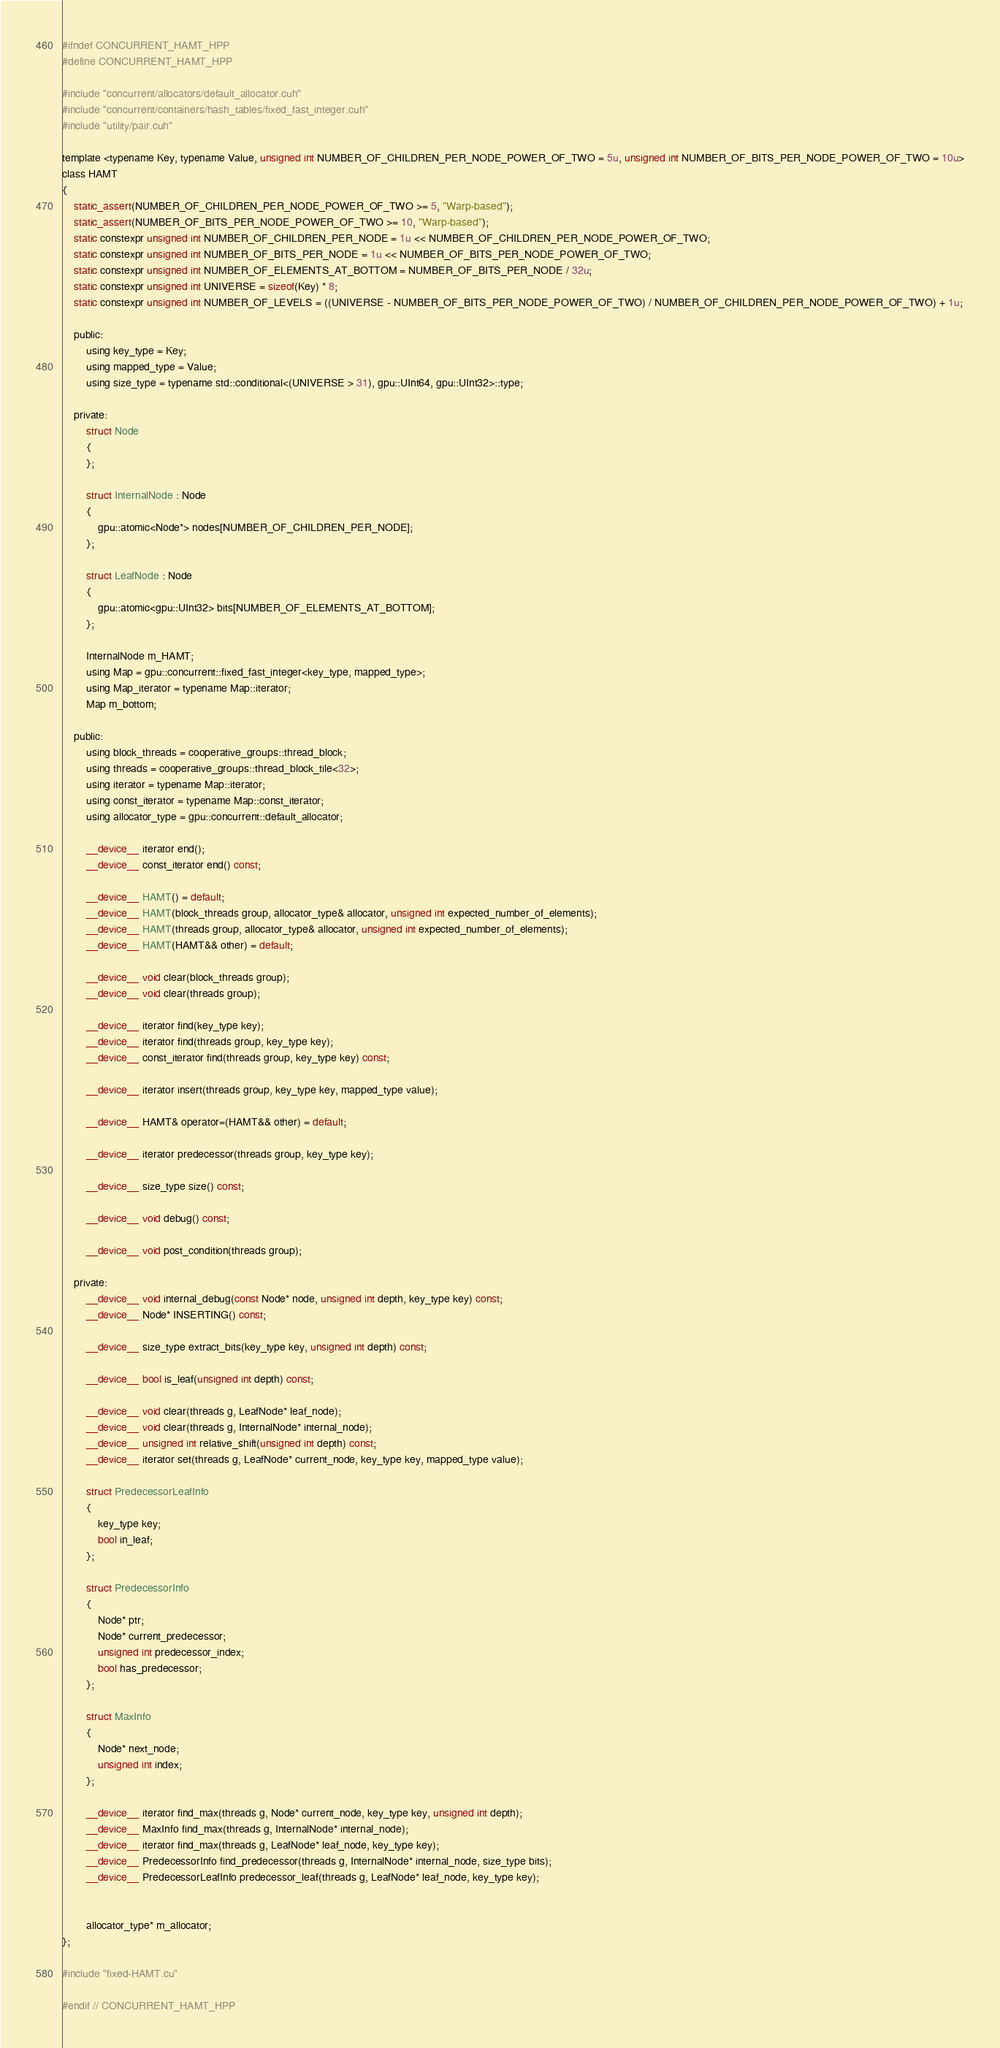<code> <loc_0><loc_0><loc_500><loc_500><_Cuda_>#ifndef CONCURRENT_HAMT_HPP
#define CONCURRENT_HAMT_HPP

#include "concurrent/allocators/default_allocator.cuh"
#include "concurrent/containers/hash_tables/fixed_fast_integer.cuh"
#include "utility/pair.cuh"

template <typename Key, typename Value, unsigned int NUMBER_OF_CHILDREN_PER_NODE_POWER_OF_TWO = 5u, unsigned int NUMBER_OF_BITS_PER_NODE_POWER_OF_TWO = 10u>
class HAMT
{
	static_assert(NUMBER_OF_CHILDREN_PER_NODE_POWER_OF_TWO >= 5, "Warp-based");
	static_assert(NUMBER_OF_BITS_PER_NODE_POWER_OF_TWO >= 10, "Warp-based");
	static constexpr unsigned int NUMBER_OF_CHILDREN_PER_NODE = 1u << NUMBER_OF_CHILDREN_PER_NODE_POWER_OF_TWO;
	static constexpr unsigned int NUMBER_OF_BITS_PER_NODE = 1u << NUMBER_OF_BITS_PER_NODE_POWER_OF_TWO;
	static constexpr unsigned int NUMBER_OF_ELEMENTS_AT_BOTTOM = NUMBER_OF_BITS_PER_NODE / 32u;
	static constexpr unsigned int UNIVERSE = sizeof(Key) * 8;
	static constexpr unsigned int NUMBER_OF_LEVELS = ((UNIVERSE - NUMBER_OF_BITS_PER_NODE_POWER_OF_TWO) / NUMBER_OF_CHILDREN_PER_NODE_POWER_OF_TWO) + 1u;

	public:
		using key_type = Key;
		using mapped_type = Value;
		using size_type = typename std::conditional<(UNIVERSE > 31), gpu::UInt64, gpu::UInt32>::type;

	private:
		struct Node
		{
		};

		struct InternalNode : Node
		{
			gpu::atomic<Node*> nodes[NUMBER_OF_CHILDREN_PER_NODE];
		};

		struct LeafNode : Node
		{
			gpu::atomic<gpu::UInt32> bits[NUMBER_OF_ELEMENTS_AT_BOTTOM];
		};

		InternalNode m_HAMT;
		using Map = gpu::concurrent::fixed_fast_integer<key_type, mapped_type>;
		using Map_iterator = typename Map::iterator;
		Map m_bottom;

	public:
		using block_threads = cooperative_groups::thread_block;
		using threads = cooperative_groups::thread_block_tile<32>;
		using iterator = typename Map::iterator;
		using const_iterator = typename Map::const_iterator;
		using allocator_type = gpu::concurrent::default_allocator;

		__device__ iterator end();
		__device__ const_iterator end() const;

		__device__ HAMT() = default;
		__device__ HAMT(block_threads group, allocator_type& allocator, unsigned int expected_number_of_elements);
		__device__ HAMT(threads group, allocator_type& allocator, unsigned int expected_number_of_elements);
		__device__ HAMT(HAMT&& other) = default;

		__device__ void clear(block_threads group);
		__device__ void clear(threads group);

		__device__ iterator find(key_type key);
		__device__ iterator find(threads group, key_type key);
		__device__ const_iterator find(threads group, key_type key) const;

		__device__ iterator insert(threads group, key_type key, mapped_type value);

		__device__ HAMT& operator=(HAMT&& other) = default;

		__device__ iterator predecessor(threads group, key_type key);

		__device__ size_type size() const;

		__device__ void debug() const;

		__device__ void post_condition(threads group);

	private:
		__device__ void internal_debug(const Node* node, unsigned int depth, key_type key) const;
		__device__ Node* INSERTING() const;

		__device__ size_type extract_bits(key_type key, unsigned int depth) const;

		__device__ bool is_leaf(unsigned int depth) const;

		__device__ void clear(threads g, LeafNode* leaf_node);
		__device__ void clear(threads g, InternalNode* internal_node);
		__device__ unsigned int relative_shift(unsigned int depth) const;
		__device__ iterator set(threads g, LeafNode* current_node, key_type key, mapped_type value);

		struct PredecessorLeafInfo
		{
			key_type key;
			bool in_leaf;
		};

		struct PredecessorInfo
		{
			Node* ptr;
			Node* current_predecessor;
			unsigned int predecessor_index;
			bool has_predecessor;
		};

		struct MaxInfo
		{
			Node* next_node;
			unsigned int index;
		};

		__device__ iterator find_max(threads g, Node* current_node, key_type key, unsigned int depth);
		__device__ MaxInfo find_max(threads g, InternalNode* internal_node);
		__device__ iterator find_max(threads g, LeafNode* leaf_node, key_type key);
		__device__ PredecessorInfo find_predecessor(threads g, InternalNode* internal_node, size_type bits);
		__device__ PredecessorLeafInfo predecessor_leaf(threads g, LeafNode* leaf_node, key_type key);
		

		allocator_type* m_allocator;
};

#include "fixed-HAMT.cu"

#endif // CONCURRENT_HAMT_HPP
</code> 